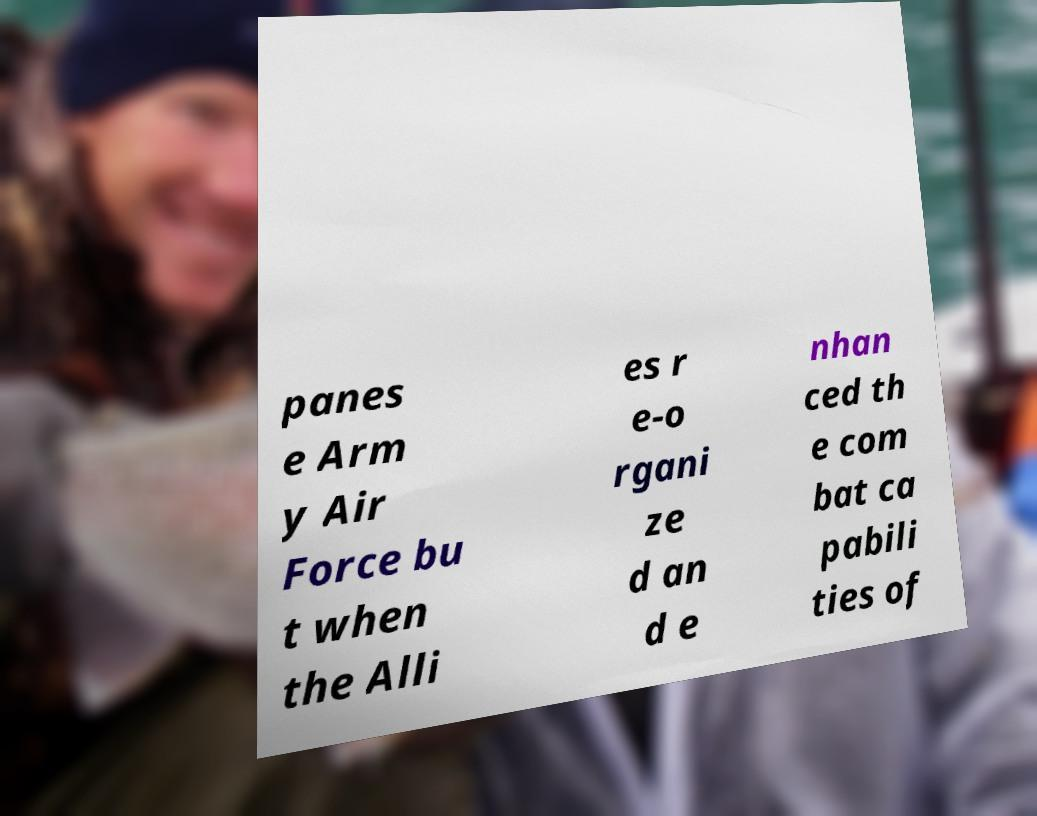Could you assist in decoding the text presented in this image and type it out clearly? panes e Arm y Air Force bu t when the Alli es r e-o rgani ze d an d e nhan ced th e com bat ca pabili ties of 